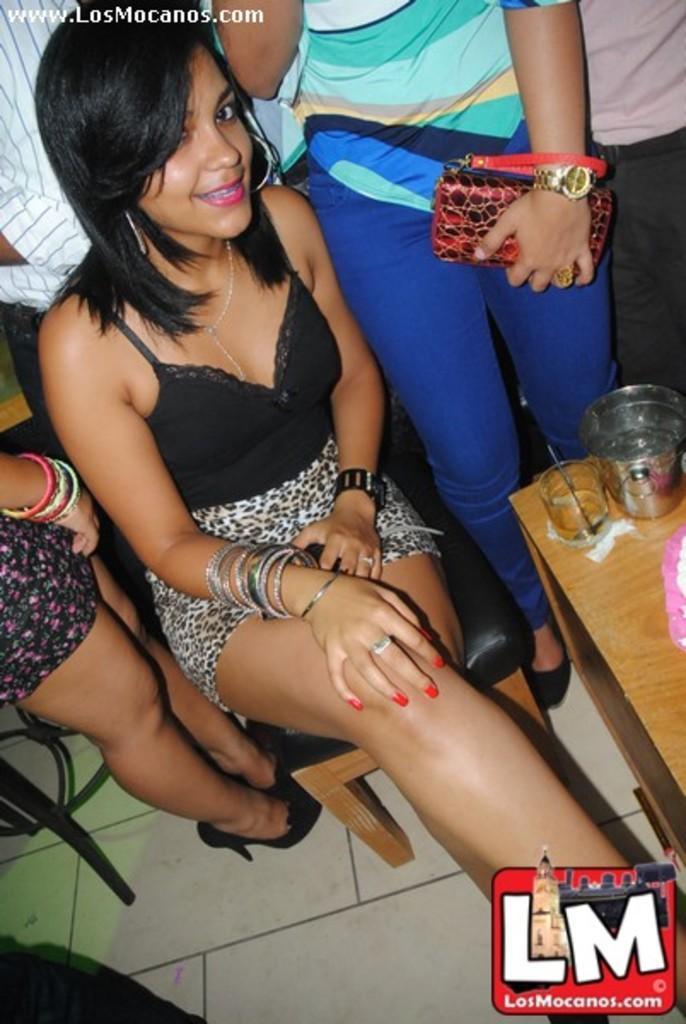In one or two sentences, can you explain what this image depicts? In this image I can see a woman sitting on the chair. Just beside this woman there is a table. In the background I can see few people are standing. 